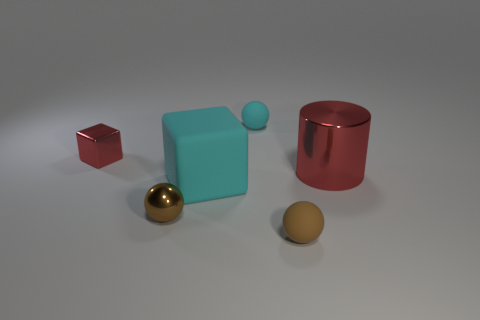How does the lighting in this scene affect the appearance of the objects? The lighting in the scene is coming from above, creating subtle shadows beneath the objects. This overhead lighting highlights the shapes and textures, enhances the metallic sheen on the cylindrical objects, and adds depth to the scene. Objects closer to the light source have less pronounced shadows, indicating a relatively even light distribution throughout.  What could be the function of these objects if they were real? If these objects were real, their function would depend on their size and material. The red and golden cylinders could be storage containers, possibly for liquids or small items. The turquoise cube could be a decorative item or a part of a larger modular structure, whilst the small red cube and golden sphere could be weights or purely ornamental objects. 